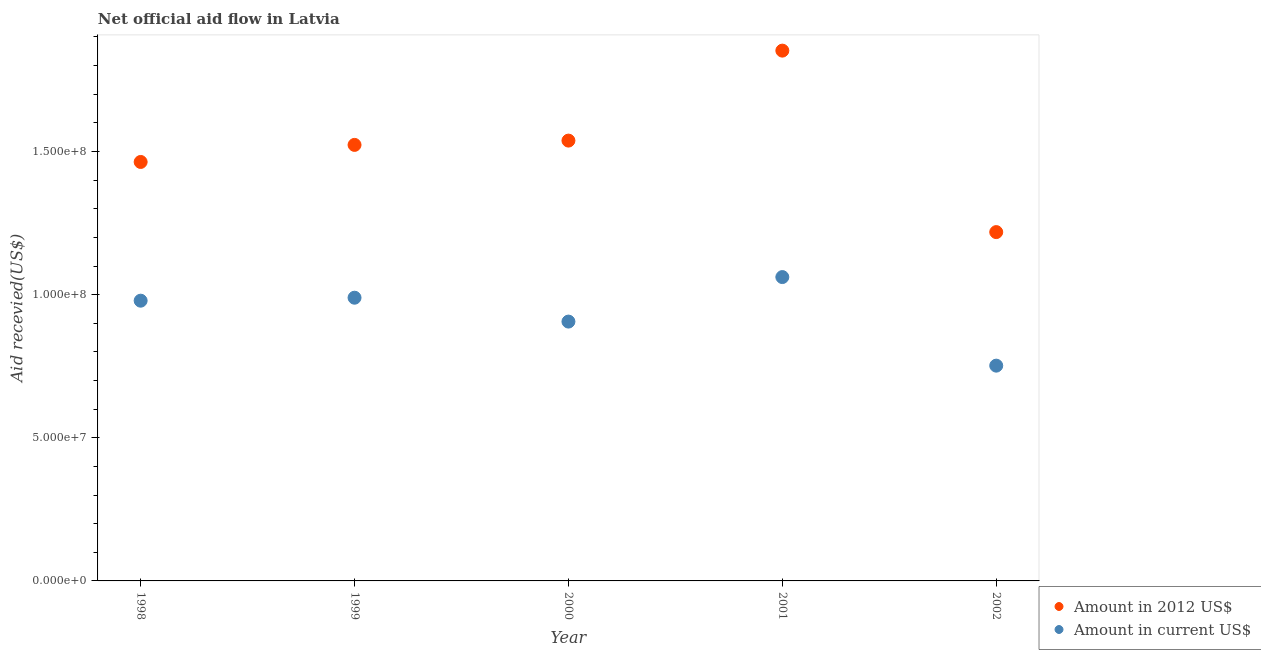How many different coloured dotlines are there?
Provide a succinct answer. 2. Is the number of dotlines equal to the number of legend labels?
Ensure brevity in your answer.  Yes. What is the amount of aid received(expressed in us$) in 2002?
Offer a very short reply. 7.52e+07. Across all years, what is the maximum amount of aid received(expressed in us$)?
Ensure brevity in your answer.  1.06e+08. Across all years, what is the minimum amount of aid received(expressed in 2012 us$)?
Make the answer very short. 1.22e+08. In which year was the amount of aid received(expressed in 2012 us$) minimum?
Give a very brief answer. 2002. What is the total amount of aid received(expressed in us$) in the graph?
Keep it short and to the point. 4.69e+08. What is the difference between the amount of aid received(expressed in us$) in 1998 and that in 1999?
Provide a short and direct response. -1.04e+06. What is the difference between the amount of aid received(expressed in us$) in 2001 and the amount of aid received(expressed in 2012 us$) in 1999?
Keep it short and to the point. -4.62e+07. What is the average amount of aid received(expressed in us$) per year?
Provide a succinct answer. 9.38e+07. In the year 2001, what is the difference between the amount of aid received(expressed in 2012 us$) and amount of aid received(expressed in us$)?
Your answer should be very brief. 7.91e+07. In how many years, is the amount of aid received(expressed in us$) greater than 80000000 US$?
Offer a very short reply. 4. What is the ratio of the amount of aid received(expressed in 2012 us$) in 1998 to that in 1999?
Give a very brief answer. 0.96. Is the amount of aid received(expressed in us$) in 1998 less than that in 2002?
Offer a very short reply. No. Is the difference between the amount of aid received(expressed in 2012 us$) in 2001 and 2002 greater than the difference between the amount of aid received(expressed in us$) in 2001 and 2002?
Offer a very short reply. Yes. What is the difference between the highest and the second highest amount of aid received(expressed in 2012 us$)?
Ensure brevity in your answer.  3.14e+07. What is the difference between the highest and the lowest amount of aid received(expressed in us$)?
Your response must be concise. 3.09e+07. In how many years, is the amount of aid received(expressed in us$) greater than the average amount of aid received(expressed in us$) taken over all years?
Offer a terse response. 3. Is the sum of the amount of aid received(expressed in 2012 us$) in 1999 and 2001 greater than the maximum amount of aid received(expressed in us$) across all years?
Make the answer very short. Yes. Does the amount of aid received(expressed in us$) monotonically increase over the years?
Make the answer very short. No. Is the amount of aid received(expressed in us$) strictly greater than the amount of aid received(expressed in 2012 us$) over the years?
Your answer should be very brief. No. Is the amount of aid received(expressed in 2012 us$) strictly less than the amount of aid received(expressed in us$) over the years?
Provide a succinct answer. No. How many years are there in the graph?
Your answer should be very brief. 5. Are the values on the major ticks of Y-axis written in scientific E-notation?
Your answer should be compact. Yes. Does the graph contain grids?
Offer a terse response. No. What is the title of the graph?
Give a very brief answer. Net official aid flow in Latvia. Does "Private consumption" appear as one of the legend labels in the graph?
Ensure brevity in your answer.  No. What is the label or title of the Y-axis?
Give a very brief answer. Aid recevied(US$). What is the Aid recevied(US$) of Amount in 2012 US$ in 1998?
Offer a terse response. 1.46e+08. What is the Aid recevied(US$) of Amount in current US$ in 1998?
Provide a succinct answer. 9.79e+07. What is the Aid recevied(US$) in Amount in 2012 US$ in 1999?
Ensure brevity in your answer.  1.52e+08. What is the Aid recevied(US$) of Amount in current US$ in 1999?
Provide a succinct answer. 9.89e+07. What is the Aid recevied(US$) in Amount in 2012 US$ in 2000?
Ensure brevity in your answer.  1.54e+08. What is the Aid recevied(US$) of Amount in current US$ in 2000?
Make the answer very short. 9.06e+07. What is the Aid recevied(US$) of Amount in 2012 US$ in 2001?
Provide a short and direct response. 1.85e+08. What is the Aid recevied(US$) in Amount in current US$ in 2001?
Your response must be concise. 1.06e+08. What is the Aid recevied(US$) of Amount in 2012 US$ in 2002?
Keep it short and to the point. 1.22e+08. What is the Aid recevied(US$) of Amount in current US$ in 2002?
Provide a short and direct response. 7.52e+07. Across all years, what is the maximum Aid recevied(US$) in Amount in 2012 US$?
Make the answer very short. 1.85e+08. Across all years, what is the maximum Aid recevied(US$) in Amount in current US$?
Your answer should be very brief. 1.06e+08. Across all years, what is the minimum Aid recevied(US$) of Amount in 2012 US$?
Give a very brief answer. 1.22e+08. Across all years, what is the minimum Aid recevied(US$) in Amount in current US$?
Your answer should be compact. 7.52e+07. What is the total Aid recevied(US$) in Amount in 2012 US$ in the graph?
Keep it short and to the point. 7.60e+08. What is the total Aid recevied(US$) in Amount in current US$ in the graph?
Ensure brevity in your answer.  4.69e+08. What is the difference between the Aid recevied(US$) of Amount in 2012 US$ in 1998 and that in 1999?
Offer a terse response. -5.96e+06. What is the difference between the Aid recevied(US$) in Amount in current US$ in 1998 and that in 1999?
Provide a succinct answer. -1.04e+06. What is the difference between the Aid recevied(US$) of Amount in 2012 US$ in 1998 and that in 2000?
Offer a very short reply. -7.46e+06. What is the difference between the Aid recevied(US$) in Amount in current US$ in 1998 and that in 2000?
Provide a succinct answer. 7.30e+06. What is the difference between the Aid recevied(US$) of Amount in 2012 US$ in 1998 and that in 2001?
Offer a terse response. -3.89e+07. What is the difference between the Aid recevied(US$) in Amount in current US$ in 1998 and that in 2001?
Give a very brief answer. -8.25e+06. What is the difference between the Aid recevied(US$) in Amount in 2012 US$ in 1998 and that in 2002?
Ensure brevity in your answer.  2.45e+07. What is the difference between the Aid recevied(US$) of Amount in current US$ in 1998 and that in 2002?
Keep it short and to the point. 2.27e+07. What is the difference between the Aid recevied(US$) of Amount in 2012 US$ in 1999 and that in 2000?
Offer a very short reply. -1.50e+06. What is the difference between the Aid recevied(US$) in Amount in current US$ in 1999 and that in 2000?
Your response must be concise. 8.34e+06. What is the difference between the Aid recevied(US$) of Amount in 2012 US$ in 1999 and that in 2001?
Keep it short and to the point. -3.29e+07. What is the difference between the Aid recevied(US$) in Amount in current US$ in 1999 and that in 2001?
Make the answer very short. -7.21e+06. What is the difference between the Aid recevied(US$) in Amount in 2012 US$ in 1999 and that in 2002?
Give a very brief answer. 3.05e+07. What is the difference between the Aid recevied(US$) of Amount in current US$ in 1999 and that in 2002?
Offer a terse response. 2.37e+07. What is the difference between the Aid recevied(US$) in Amount in 2012 US$ in 2000 and that in 2001?
Provide a succinct answer. -3.14e+07. What is the difference between the Aid recevied(US$) of Amount in current US$ in 2000 and that in 2001?
Offer a very short reply. -1.56e+07. What is the difference between the Aid recevied(US$) of Amount in 2012 US$ in 2000 and that in 2002?
Offer a terse response. 3.20e+07. What is the difference between the Aid recevied(US$) in Amount in current US$ in 2000 and that in 2002?
Keep it short and to the point. 1.54e+07. What is the difference between the Aid recevied(US$) of Amount in 2012 US$ in 2001 and that in 2002?
Your response must be concise. 6.34e+07. What is the difference between the Aid recevied(US$) of Amount in current US$ in 2001 and that in 2002?
Your response must be concise. 3.09e+07. What is the difference between the Aid recevied(US$) in Amount in 2012 US$ in 1998 and the Aid recevied(US$) in Amount in current US$ in 1999?
Keep it short and to the point. 4.74e+07. What is the difference between the Aid recevied(US$) of Amount in 2012 US$ in 1998 and the Aid recevied(US$) of Amount in current US$ in 2000?
Your answer should be very brief. 5.58e+07. What is the difference between the Aid recevied(US$) of Amount in 2012 US$ in 1998 and the Aid recevied(US$) of Amount in current US$ in 2001?
Ensure brevity in your answer.  4.02e+07. What is the difference between the Aid recevied(US$) in Amount in 2012 US$ in 1998 and the Aid recevied(US$) in Amount in current US$ in 2002?
Offer a terse response. 7.12e+07. What is the difference between the Aid recevied(US$) of Amount in 2012 US$ in 1999 and the Aid recevied(US$) of Amount in current US$ in 2000?
Offer a terse response. 6.17e+07. What is the difference between the Aid recevied(US$) in Amount in 2012 US$ in 1999 and the Aid recevied(US$) in Amount in current US$ in 2001?
Provide a succinct answer. 4.62e+07. What is the difference between the Aid recevied(US$) in Amount in 2012 US$ in 1999 and the Aid recevied(US$) in Amount in current US$ in 2002?
Your answer should be compact. 7.71e+07. What is the difference between the Aid recevied(US$) in Amount in 2012 US$ in 2000 and the Aid recevied(US$) in Amount in current US$ in 2001?
Provide a succinct answer. 4.77e+07. What is the difference between the Aid recevied(US$) in Amount in 2012 US$ in 2000 and the Aid recevied(US$) in Amount in current US$ in 2002?
Provide a succinct answer. 7.86e+07. What is the difference between the Aid recevied(US$) of Amount in 2012 US$ in 2001 and the Aid recevied(US$) of Amount in current US$ in 2002?
Your response must be concise. 1.10e+08. What is the average Aid recevied(US$) in Amount in 2012 US$ per year?
Provide a succinct answer. 1.52e+08. What is the average Aid recevied(US$) in Amount in current US$ per year?
Make the answer very short. 9.38e+07. In the year 1998, what is the difference between the Aid recevied(US$) of Amount in 2012 US$ and Aid recevied(US$) of Amount in current US$?
Your response must be concise. 4.85e+07. In the year 1999, what is the difference between the Aid recevied(US$) in Amount in 2012 US$ and Aid recevied(US$) in Amount in current US$?
Give a very brief answer. 5.34e+07. In the year 2000, what is the difference between the Aid recevied(US$) in Amount in 2012 US$ and Aid recevied(US$) in Amount in current US$?
Make the answer very short. 6.32e+07. In the year 2001, what is the difference between the Aid recevied(US$) in Amount in 2012 US$ and Aid recevied(US$) in Amount in current US$?
Keep it short and to the point. 7.91e+07. In the year 2002, what is the difference between the Aid recevied(US$) of Amount in 2012 US$ and Aid recevied(US$) of Amount in current US$?
Make the answer very short. 4.66e+07. What is the ratio of the Aid recevied(US$) in Amount in 2012 US$ in 1998 to that in 1999?
Your response must be concise. 0.96. What is the ratio of the Aid recevied(US$) of Amount in current US$ in 1998 to that in 1999?
Give a very brief answer. 0.99. What is the ratio of the Aid recevied(US$) in Amount in 2012 US$ in 1998 to that in 2000?
Ensure brevity in your answer.  0.95. What is the ratio of the Aid recevied(US$) of Amount in current US$ in 1998 to that in 2000?
Provide a short and direct response. 1.08. What is the ratio of the Aid recevied(US$) of Amount in 2012 US$ in 1998 to that in 2001?
Your answer should be very brief. 0.79. What is the ratio of the Aid recevied(US$) of Amount in current US$ in 1998 to that in 2001?
Keep it short and to the point. 0.92. What is the ratio of the Aid recevied(US$) in Amount in 2012 US$ in 1998 to that in 2002?
Ensure brevity in your answer.  1.2. What is the ratio of the Aid recevied(US$) of Amount in current US$ in 1998 to that in 2002?
Make the answer very short. 1.3. What is the ratio of the Aid recevied(US$) in Amount in 2012 US$ in 1999 to that in 2000?
Keep it short and to the point. 0.99. What is the ratio of the Aid recevied(US$) of Amount in current US$ in 1999 to that in 2000?
Provide a short and direct response. 1.09. What is the ratio of the Aid recevied(US$) in Amount in 2012 US$ in 1999 to that in 2001?
Offer a very short reply. 0.82. What is the ratio of the Aid recevied(US$) of Amount in current US$ in 1999 to that in 2001?
Provide a succinct answer. 0.93. What is the ratio of the Aid recevied(US$) in Amount in 2012 US$ in 1999 to that in 2002?
Ensure brevity in your answer.  1.25. What is the ratio of the Aid recevied(US$) in Amount in current US$ in 1999 to that in 2002?
Your response must be concise. 1.32. What is the ratio of the Aid recevied(US$) in Amount in 2012 US$ in 2000 to that in 2001?
Provide a short and direct response. 0.83. What is the ratio of the Aid recevied(US$) of Amount in current US$ in 2000 to that in 2001?
Make the answer very short. 0.85. What is the ratio of the Aid recevied(US$) of Amount in 2012 US$ in 2000 to that in 2002?
Make the answer very short. 1.26. What is the ratio of the Aid recevied(US$) in Amount in current US$ in 2000 to that in 2002?
Provide a succinct answer. 1.2. What is the ratio of the Aid recevied(US$) of Amount in 2012 US$ in 2001 to that in 2002?
Offer a very short reply. 1.52. What is the ratio of the Aid recevied(US$) in Amount in current US$ in 2001 to that in 2002?
Offer a very short reply. 1.41. What is the difference between the highest and the second highest Aid recevied(US$) in Amount in 2012 US$?
Offer a very short reply. 3.14e+07. What is the difference between the highest and the second highest Aid recevied(US$) in Amount in current US$?
Your answer should be compact. 7.21e+06. What is the difference between the highest and the lowest Aid recevied(US$) in Amount in 2012 US$?
Your response must be concise. 6.34e+07. What is the difference between the highest and the lowest Aid recevied(US$) of Amount in current US$?
Your response must be concise. 3.09e+07. 